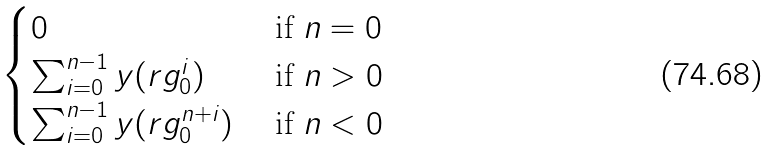<formula> <loc_0><loc_0><loc_500><loc_500>\begin{cases} 0 & \text { if } n = 0 \\ \sum _ { i = 0 } ^ { n - 1 } y ( r g _ { 0 } ^ { i } ) & \text { if } n > 0 \\ \sum _ { i = 0 } ^ { n - 1 } y ( r g _ { 0 } ^ { n + i } ) & \text { if } n < 0 \\ \end{cases}</formula> 